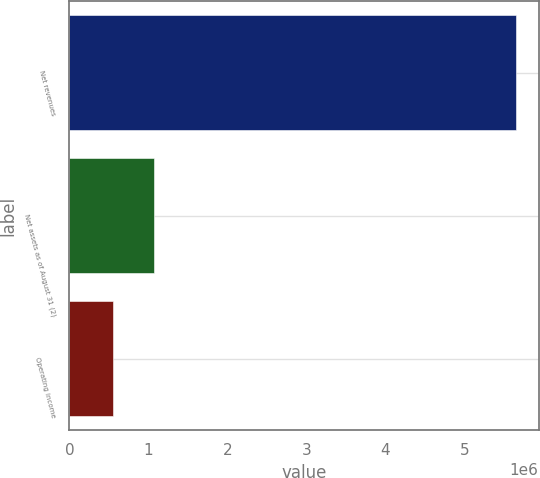Convert chart. <chart><loc_0><loc_0><loc_500><loc_500><bar_chart><fcel>Net revenues<fcel>Net assets as of August 31 (2)<fcel>Operating income<nl><fcel>5.65718e+06<fcel>1.065e+06<fcel>554760<nl></chart> 